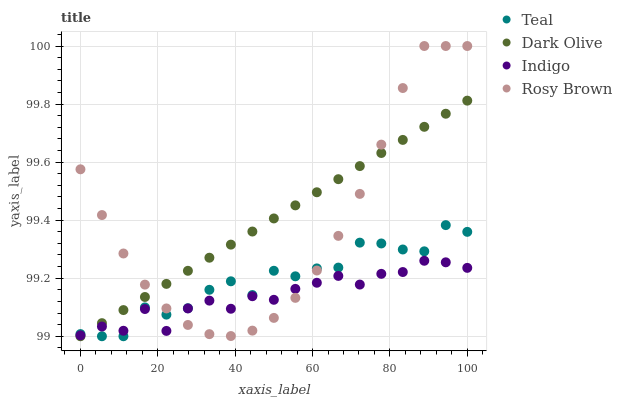Does Indigo have the minimum area under the curve?
Answer yes or no. Yes. Does Dark Olive have the maximum area under the curve?
Answer yes or no. Yes. Does Dark Olive have the minimum area under the curve?
Answer yes or no. No. Does Indigo have the maximum area under the curve?
Answer yes or no. No. Is Dark Olive the smoothest?
Answer yes or no. Yes. Is Teal the roughest?
Answer yes or no. Yes. Is Indigo the smoothest?
Answer yes or no. No. Is Indigo the roughest?
Answer yes or no. No. Does Dark Olive have the lowest value?
Answer yes or no. Yes. Does Indigo have the lowest value?
Answer yes or no. No. Does Rosy Brown have the highest value?
Answer yes or no. Yes. Does Dark Olive have the highest value?
Answer yes or no. No. Does Indigo intersect Dark Olive?
Answer yes or no. Yes. Is Indigo less than Dark Olive?
Answer yes or no. No. Is Indigo greater than Dark Olive?
Answer yes or no. No. 